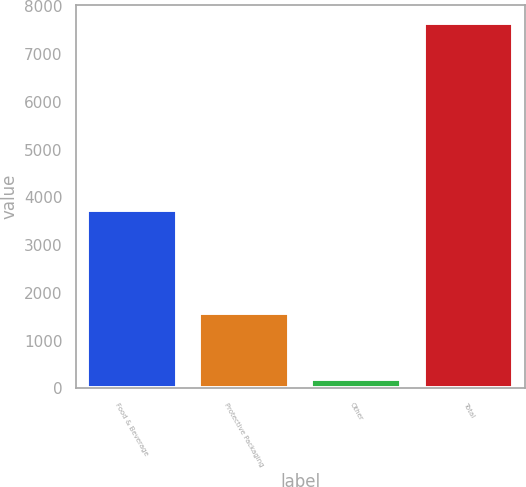<chart> <loc_0><loc_0><loc_500><loc_500><bar_chart><fcel>Food & Beverage<fcel>Protective Packaging<fcel>Other<fcel>Total<nl><fcel>3739.6<fcel>1578.4<fcel>198.6<fcel>7648.1<nl></chart> 